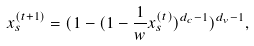Convert formula to latex. <formula><loc_0><loc_0><loc_500><loc_500>x _ { s } ^ { ( t + 1 ) } = ( 1 - ( 1 - \frac { 1 } { w } x _ { s } ^ { ( t ) } ) ^ { d _ { c } - 1 } ) ^ { d _ { v } - 1 } ,</formula> 